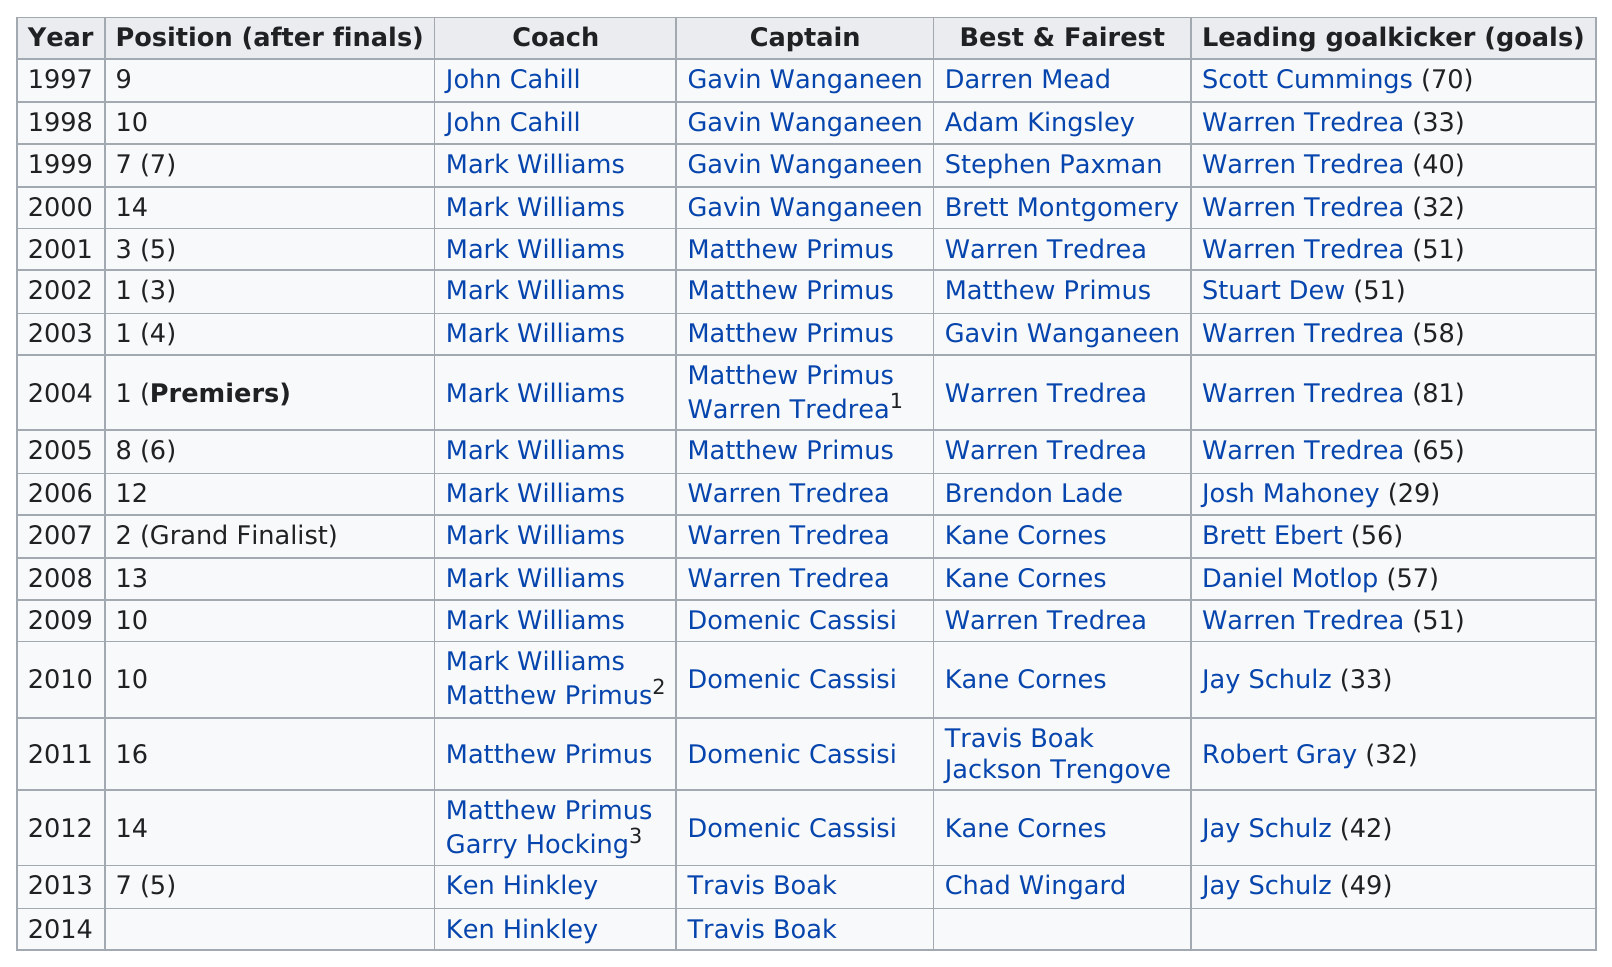List a handful of essential elements in this visual. Warren Tredrea, who served as the AFL captain and was considered the best and fairest player during the 2004 premiership season, is a prominent Australian rules footballer. Warren Tredrea was the highest leading goal-kicker from the years 1997 to 2014. In 2004, Warren Tredrea led all players in the number of goals scored. 